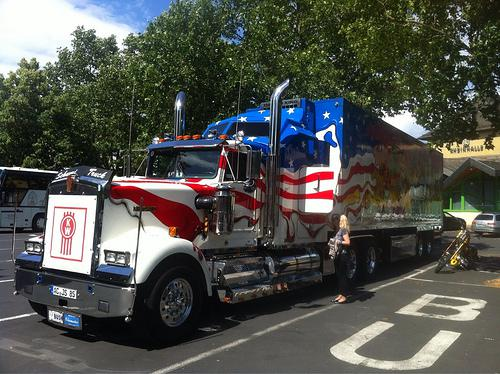Question: who is near the truck?
Choices:
A. Blonde boy.
B. Blonde man.
C. Blonde woman.
D. Blonde girl.
Answer with the letter. Answer: C Question: what design is on the truck?
Choices:
A. Stripes.
B. Flag.
C. Checkered.
D. Polka dots.
Answer with the letter. Answer: B Question: what is the weather like?
Choices:
A. Stormy.
B. Overcast.
C. Rainy.
D. Sunny.
Answer with the letter. Answer: D Question: why is the bus decorated?
Choices:
A. For a parade.
B. To tell its location.
C. For a party.
D. Patriotic.
Answer with the letter. Answer: D 